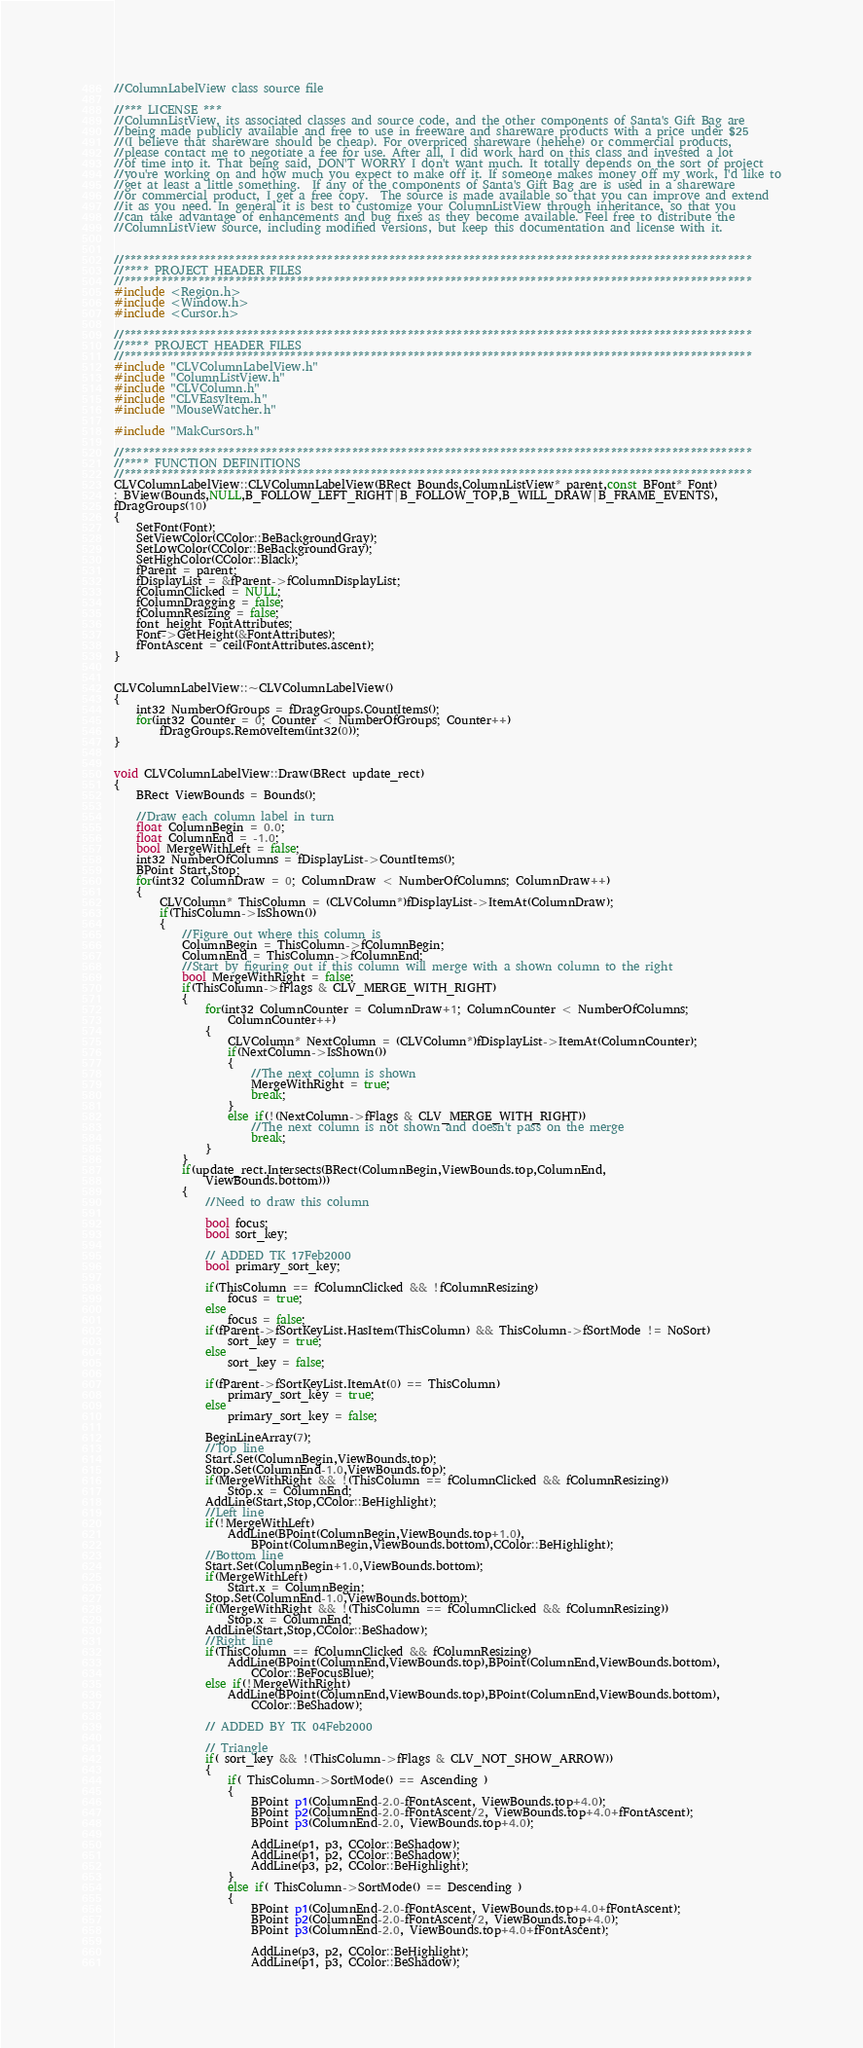<code> <loc_0><loc_0><loc_500><loc_500><_C++_>//ColumnLabelView class source file

//*** LICENSE ***
//ColumnListView, its associated classes and source code, and the other components of Santa's Gift Bag are
//being made publicly available and free to use in freeware and shareware products with a price under $25
//(I believe that shareware should be cheap). For overpriced shareware (hehehe) or commercial products,
//please contact me to negotiate a fee for use. After all, I did work hard on this class and invested a lot
//of time into it. That being said, DON'T WORRY I don't want much. It totally depends on the sort of project
//you're working on and how much you expect to make off it. If someone makes money off my work, I'd like to
//get at least a little something.  If any of the components of Santa's Gift Bag are is used in a shareware
//or commercial product, I get a free copy.  The source is made available so that you can improve and extend
//it as you need. In general it is best to customize your ColumnListView through inheritance, so that you
//can take advantage of enhancements and bug fixes as they become available. Feel free to distribute the 
//ColumnListView source, including modified versions, but keep this documentation and license with it.


//******************************************************************************************************
//**** PROJECT HEADER FILES
//******************************************************************************************************
#include <Region.h>
#include <Window.h>
#include <Cursor.h>

//******************************************************************************************************
//**** PROJECT HEADER FILES
//******************************************************************************************************
#include "CLVColumnLabelView.h"
#include "ColumnListView.h"
#include "CLVColumn.h"
#include "CLVEasyItem.h"
#include "MouseWatcher.h"

#include "MakCursors.h"

//******************************************************************************************************
//**** FUNCTION DEFINITIONS
//******************************************************************************************************
CLVColumnLabelView::CLVColumnLabelView(BRect Bounds,ColumnListView* parent,const BFont* Font)
: BView(Bounds,NULL,B_FOLLOW_LEFT_RIGHT|B_FOLLOW_TOP,B_WILL_DRAW|B_FRAME_EVENTS),
fDragGroups(10)
{
	SetFont(Font);
	SetViewColor(CColor::BeBackgroundGray);
	SetLowColor(CColor::BeBackgroundGray);
	SetHighColor(CColor::Black);
	fParent = parent;
	fDisplayList = &fParent->fColumnDisplayList;
	fColumnClicked = NULL;
	fColumnDragging = false;
	fColumnResizing = false;
	font_height FontAttributes;
	Font->GetHeight(&FontAttributes);
	fFontAscent = ceil(FontAttributes.ascent);
}


CLVColumnLabelView::~CLVColumnLabelView()
{
	int32 NumberOfGroups = fDragGroups.CountItems();
	for(int32 Counter = 0; Counter < NumberOfGroups; Counter++)
		fDragGroups.RemoveItem(int32(0));
}


void CLVColumnLabelView::Draw(BRect update_rect)
{
	BRect ViewBounds = Bounds();

	//Draw each column label in turn
	float ColumnBegin = 0.0;
	float ColumnEnd = -1.0;
	bool MergeWithLeft = false;
	int32 NumberOfColumns = fDisplayList->CountItems();
	BPoint Start,Stop;
	for(int32 ColumnDraw = 0; ColumnDraw < NumberOfColumns; ColumnDraw++)
	{
		CLVColumn* ThisColumn = (CLVColumn*)fDisplayList->ItemAt(ColumnDraw);
		if(ThisColumn->IsShown())
		{
			//Figure out where this column is
			ColumnBegin = ThisColumn->fColumnBegin;
			ColumnEnd = ThisColumn->fColumnEnd;
			//Start by figuring out if this column will merge with a shown column to the right
			bool MergeWithRight = false;
			if(ThisColumn->fFlags & CLV_MERGE_WITH_RIGHT)
			{
				for(int32 ColumnCounter = ColumnDraw+1; ColumnCounter < NumberOfColumns;
					ColumnCounter++)
				{
					CLVColumn* NextColumn = (CLVColumn*)fDisplayList->ItemAt(ColumnCounter);
					if(NextColumn->IsShown())
					{
						//The next column is shown
						MergeWithRight = true;
						break;
					}
					else if(!(NextColumn->fFlags & CLV_MERGE_WITH_RIGHT))
						//The next column is not shown and doesn't pass on the merge
						break;
				}
			}
			if(update_rect.Intersects(BRect(ColumnBegin,ViewBounds.top,ColumnEnd,
				ViewBounds.bottom)))
			{
				//Need to draw this column

				bool focus;
				bool sort_key;
		
				// ADDED TK 17Feb2000
				bool primary_sort_key;
				
				if(ThisColumn == fColumnClicked && !fColumnResizing)
					focus = true;
				else
					focus = false;
				if(fParent->fSortKeyList.HasItem(ThisColumn) && ThisColumn->fSortMode != NoSort)
					sort_key = true;
				else
					sort_key = false;

				if(fParent->fSortKeyList.ItemAt(0) == ThisColumn)
					primary_sort_key = true;
				else
					primary_sort_key = false;

				BeginLineArray(7);
				//Top line
				Start.Set(ColumnBegin,ViewBounds.top);
				Stop.Set(ColumnEnd-1.0,ViewBounds.top);
				if(MergeWithRight && !(ThisColumn == fColumnClicked && fColumnResizing))
					Stop.x = ColumnEnd;
				AddLine(Start,Stop,CColor::BeHighlight);
				//Left line
				if(!MergeWithLeft)
					AddLine(BPoint(ColumnBegin,ViewBounds.top+1.0),
						BPoint(ColumnBegin,ViewBounds.bottom),CColor::BeHighlight);
				//Bottom line
				Start.Set(ColumnBegin+1.0,ViewBounds.bottom);
				if(MergeWithLeft)
					Start.x = ColumnBegin;
				Stop.Set(ColumnEnd-1.0,ViewBounds.bottom);
				if(MergeWithRight && !(ThisColumn == fColumnClicked && fColumnResizing))
					Stop.x = ColumnEnd;
				AddLine(Start,Stop,CColor::BeShadow);
				//Right line
				if(ThisColumn == fColumnClicked && fColumnResizing)
					AddLine(BPoint(ColumnEnd,ViewBounds.top),BPoint(ColumnEnd,ViewBounds.bottom),
						CColor::BeFocusBlue);
				else if(!MergeWithRight)
					AddLine(BPoint(ColumnEnd,ViewBounds.top),BPoint(ColumnEnd,ViewBounds.bottom),
						CColor::BeShadow);

				// ADDED BY TK 04Feb2000
				
				// Triangle
				if( sort_key && !(ThisColumn->fFlags & CLV_NOT_SHOW_ARROW))
				{			
					if( ThisColumn->SortMode() == Ascending )
					{
						BPoint p1(ColumnEnd-2.0-fFontAscent, ViewBounds.top+4.0);
						BPoint p2(ColumnEnd-2.0-fFontAscent/2, ViewBounds.top+4.0+fFontAscent);
						BPoint p3(ColumnEnd-2.0, ViewBounds.top+4.0);
						
						AddLine(p1, p3, CColor::BeShadow);
						AddLine(p1, p2, CColor::BeShadow);
						AddLine(p3, p2, CColor::BeHighlight);
					} 
					else if( ThisColumn->SortMode() == Descending ) 
					{
						BPoint p1(ColumnEnd-2.0-fFontAscent, ViewBounds.top+4.0+fFontAscent);
						BPoint p2(ColumnEnd-2.0-fFontAscent/2, ViewBounds.top+4.0);
						BPoint p3(ColumnEnd-2.0, ViewBounds.top+4.0+fFontAscent);
						
						AddLine(p3, p2, CColor::BeHighlight);
						AddLine(p1, p3, CColor::BeShadow);</code> 